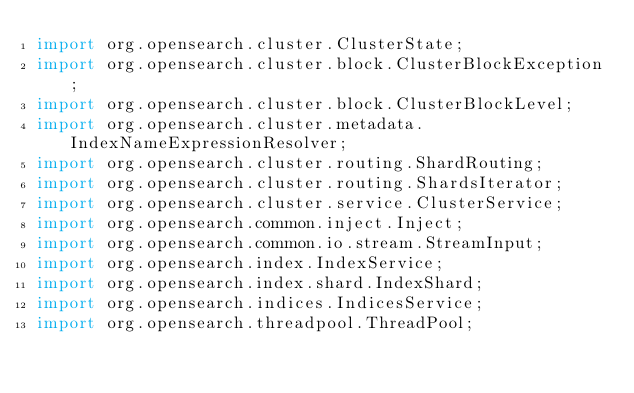Convert code to text. <code><loc_0><loc_0><loc_500><loc_500><_Java_>import org.opensearch.cluster.ClusterState;
import org.opensearch.cluster.block.ClusterBlockException;
import org.opensearch.cluster.block.ClusterBlockLevel;
import org.opensearch.cluster.metadata.IndexNameExpressionResolver;
import org.opensearch.cluster.routing.ShardRouting;
import org.opensearch.cluster.routing.ShardsIterator;
import org.opensearch.cluster.service.ClusterService;
import org.opensearch.common.inject.Inject;
import org.opensearch.common.io.stream.StreamInput;
import org.opensearch.index.IndexService;
import org.opensearch.index.shard.IndexShard;
import org.opensearch.indices.IndicesService;
import org.opensearch.threadpool.ThreadPool;</code> 